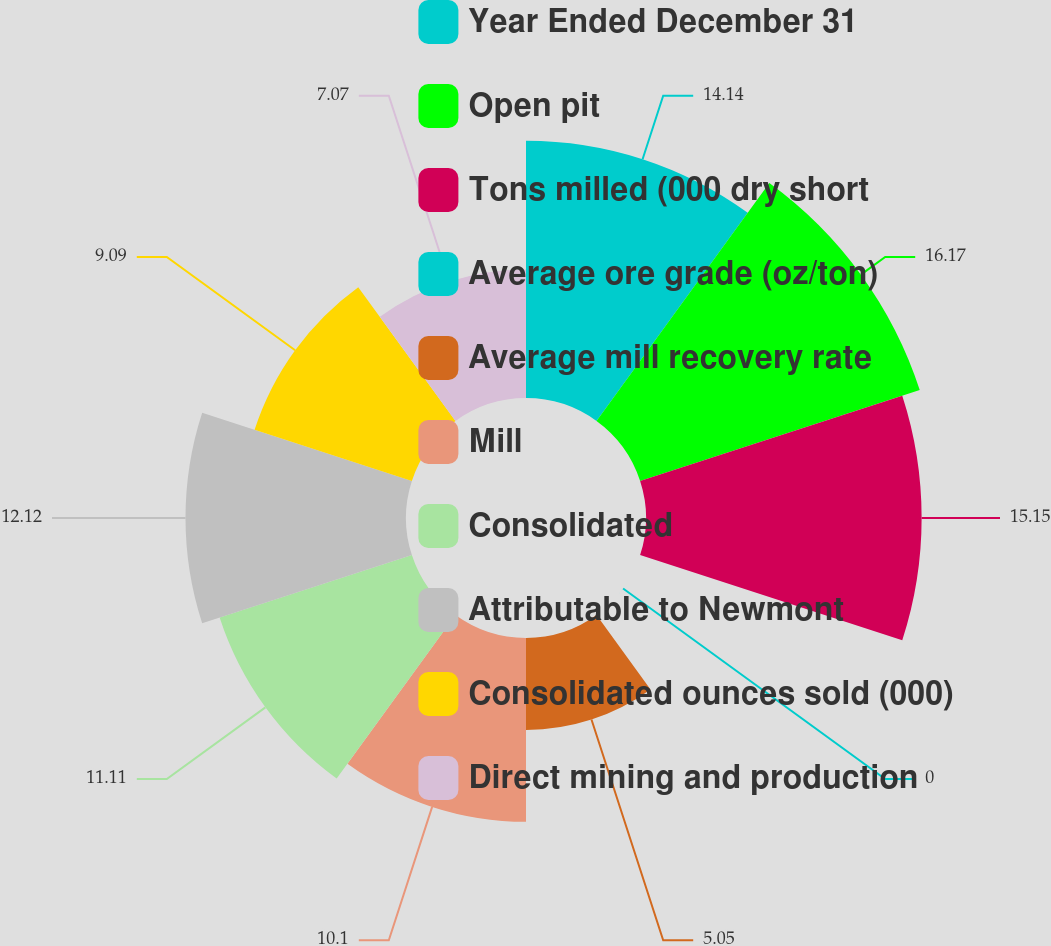Convert chart to OTSL. <chart><loc_0><loc_0><loc_500><loc_500><pie_chart><fcel>Year Ended December 31<fcel>Open pit<fcel>Tons milled (000 dry short<fcel>Average ore grade (oz/ton)<fcel>Average mill recovery rate<fcel>Mill<fcel>Consolidated<fcel>Attributable to Newmont<fcel>Consolidated ounces sold (000)<fcel>Direct mining and production<nl><fcel>14.14%<fcel>16.16%<fcel>15.15%<fcel>0.0%<fcel>5.05%<fcel>10.1%<fcel>11.11%<fcel>12.12%<fcel>9.09%<fcel>7.07%<nl></chart> 